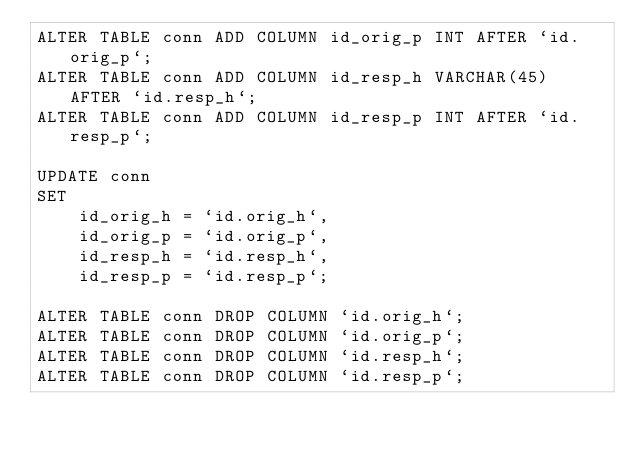<code> <loc_0><loc_0><loc_500><loc_500><_SQL_>ALTER TABLE conn ADD COLUMN id_orig_p INT AFTER `id.orig_p`;
ALTER TABLE conn ADD COLUMN id_resp_h VARCHAR(45) AFTER `id.resp_h`;
ALTER TABLE conn ADD COLUMN id_resp_p INT AFTER `id.resp_p`;

UPDATE conn
SET
		id_orig_h = `id.orig_h`,
		id_orig_p = `id.orig_p`,
		id_resp_h = `id.resp_h`,
		id_resp_p = `id.resp_p`;

ALTER TABLE conn DROP COLUMN `id.orig_h`;
ALTER TABLE conn DROP COLUMN `id.orig_p`;
ALTER TABLE conn DROP COLUMN `id.resp_h`;
ALTER TABLE conn DROP COLUMN `id.resp_p`;
</code> 